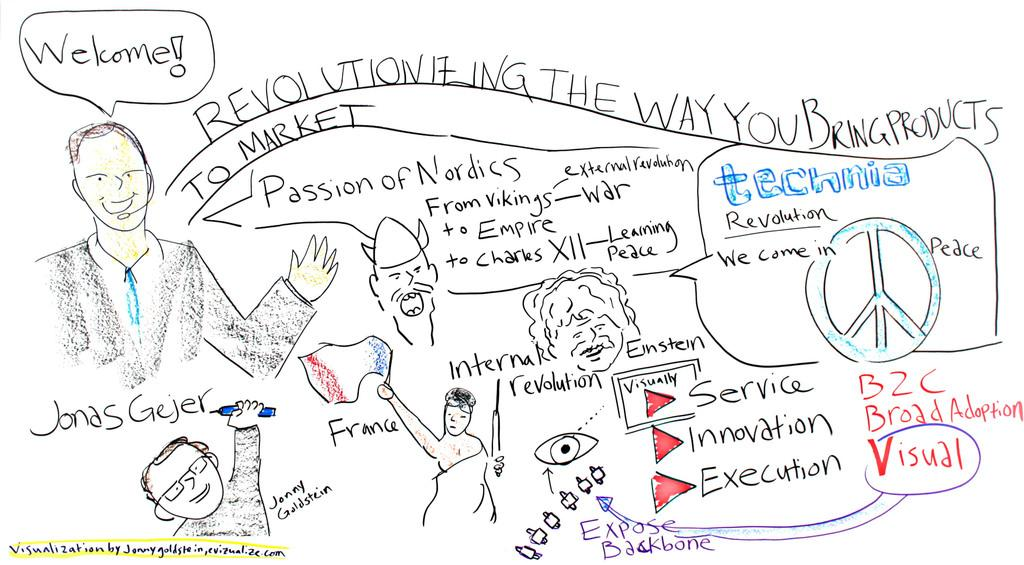What type of artwork is visible in the image? There are pencil sketches in the image. What else can be seen in the image besides the pencil sketches? There is text in the image. What type of bone is being shaken in the image? There is no bone or shaking depicted in the image; it only contains pencil sketches and text. 